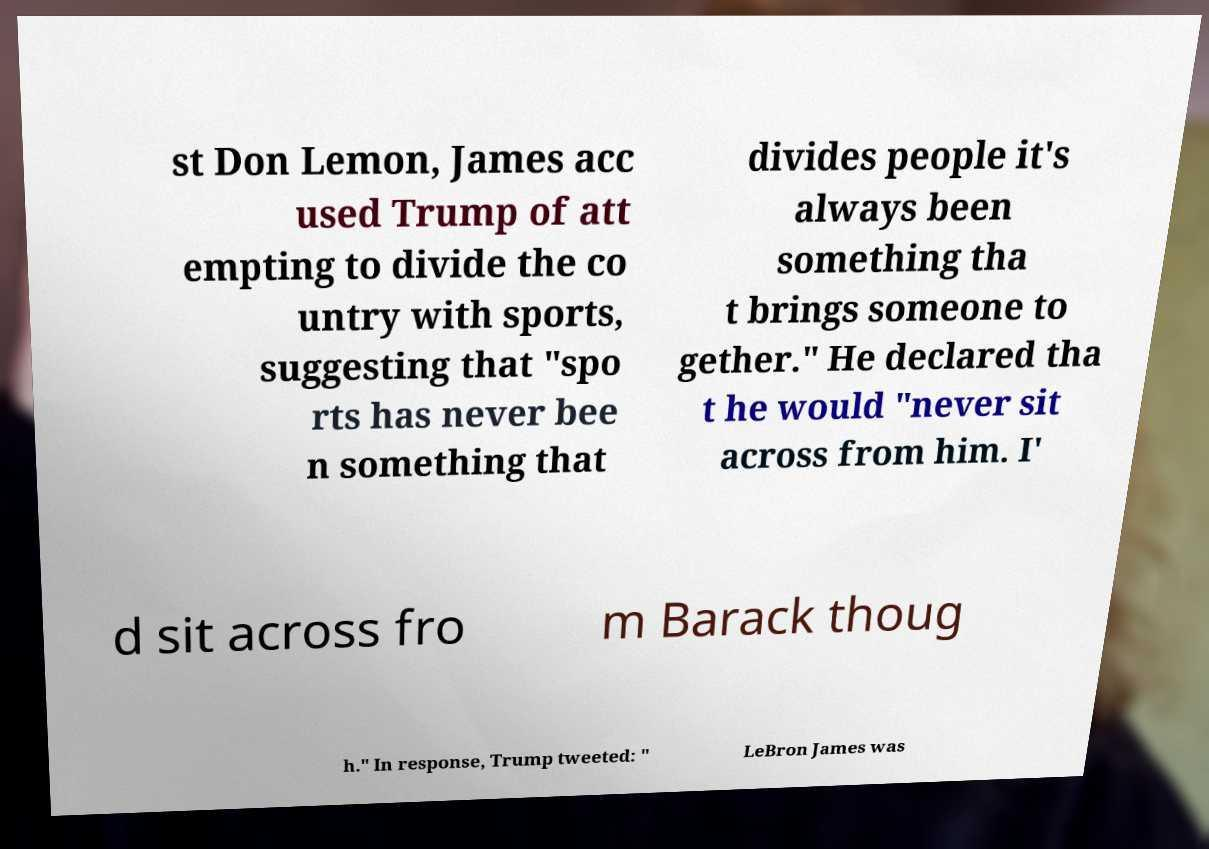For documentation purposes, I need the text within this image transcribed. Could you provide that? st Don Lemon, James acc used Trump of att empting to divide the co untry with sports, suggesting that "spo rts has never bee n something that divides people it's always been something tha t brings someone to gether." He declared tha t he would "never sit across from him. I' d sit across fro m Barack thoug h." In response, Trump tweeted: " LeBron James was 